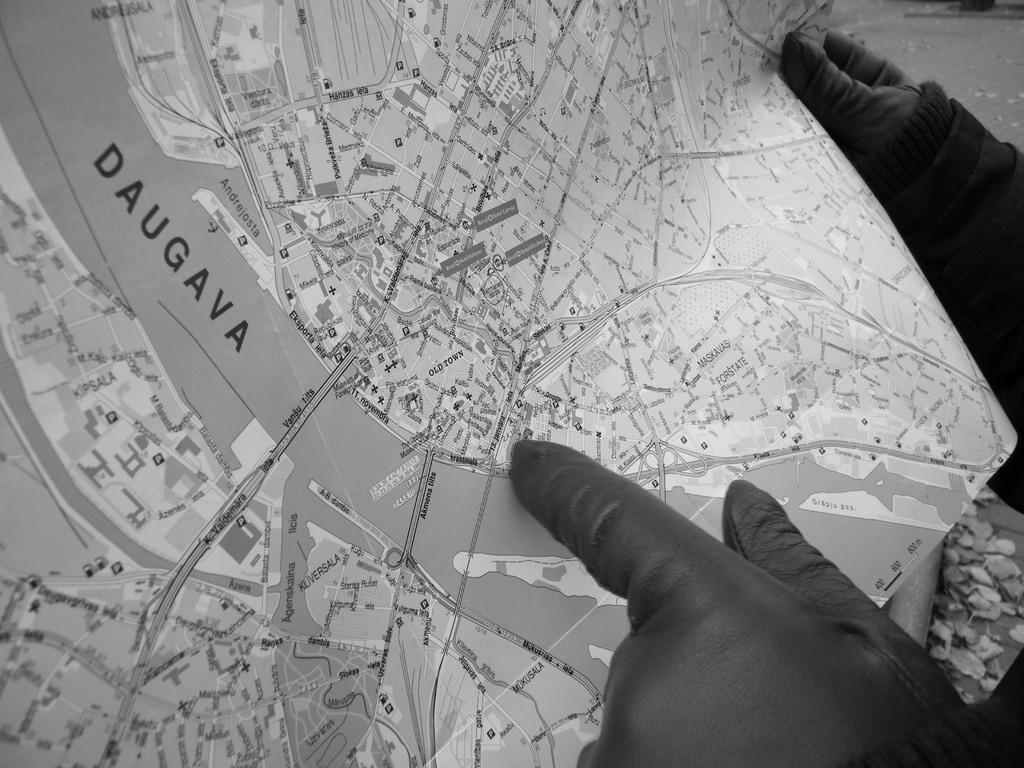In one or two sentences, can you explain what this image depicts? In this image we can see a person holding a paper, in the paper, we can see the route map, on the floor we can see some pieces of papers. 